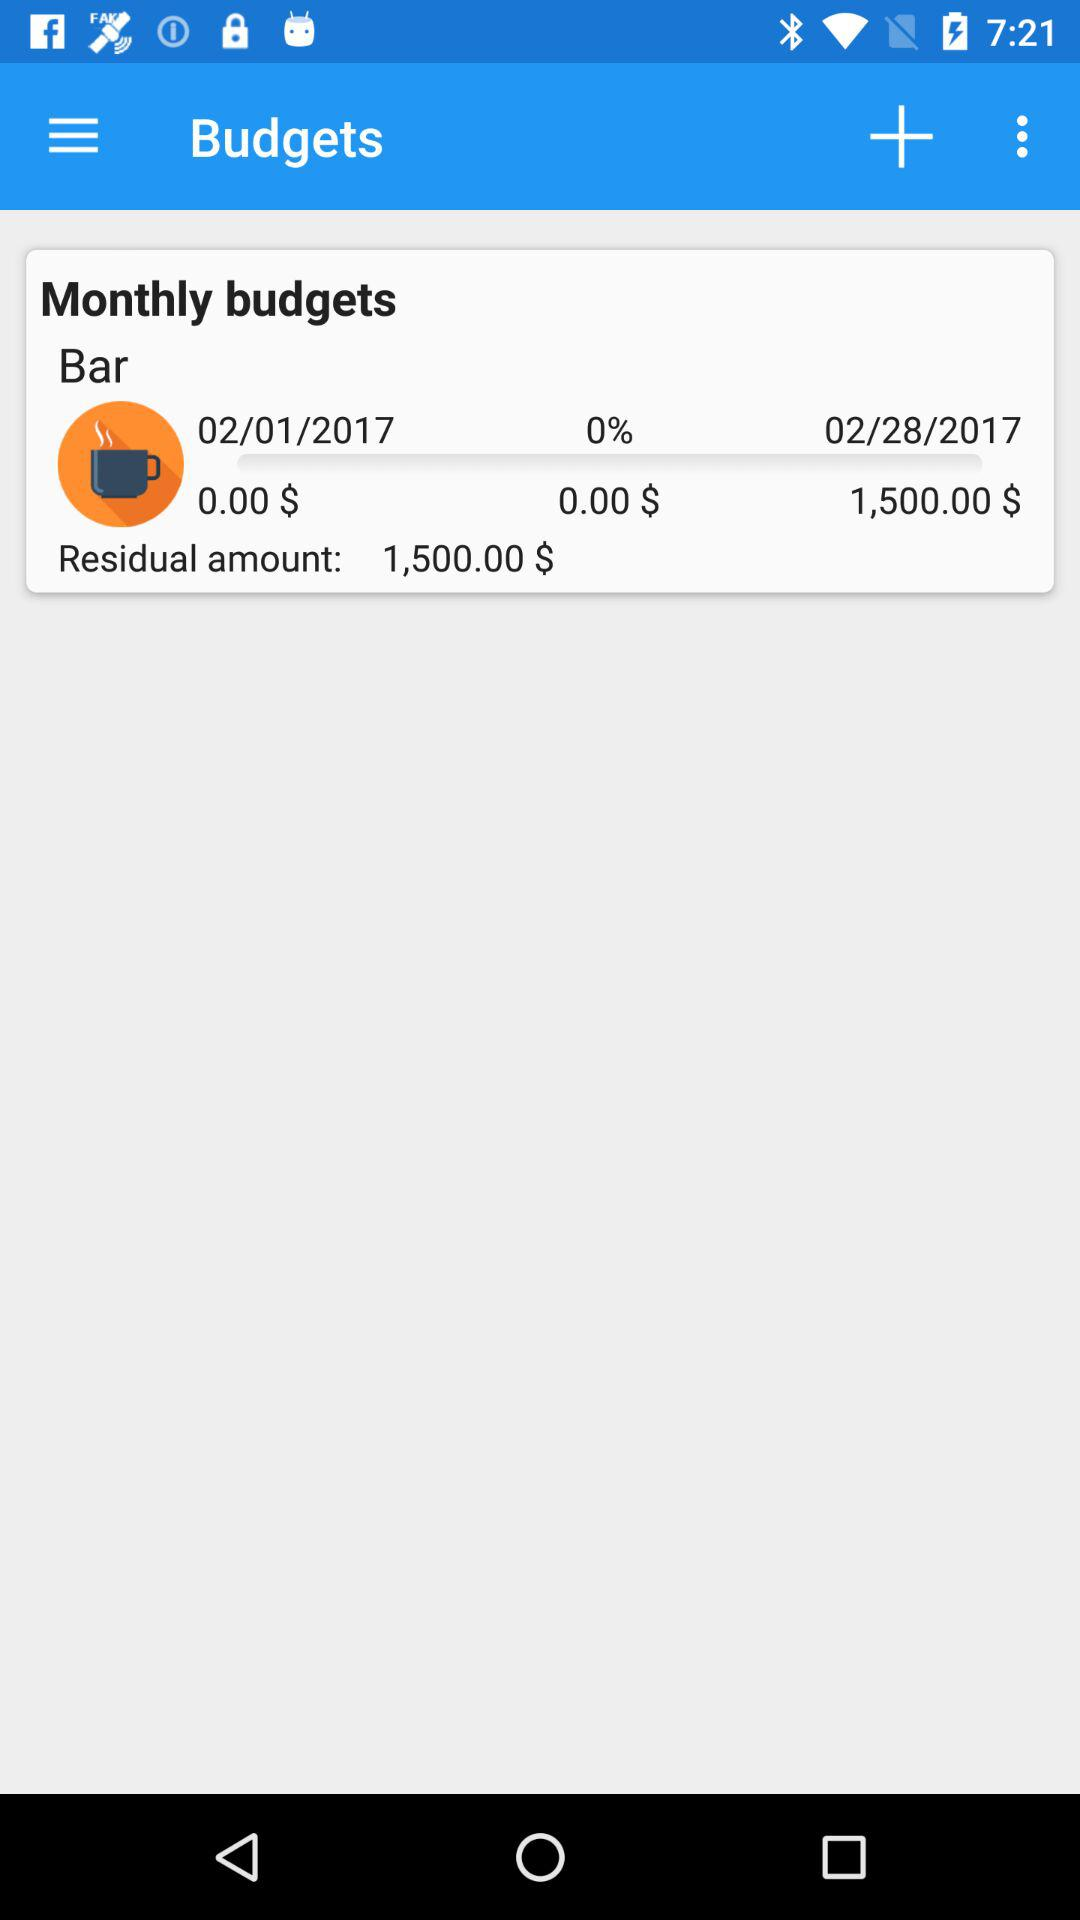What is the percentage of the budget that has been spent?
Answer the question using a single word or phrase. 0% 